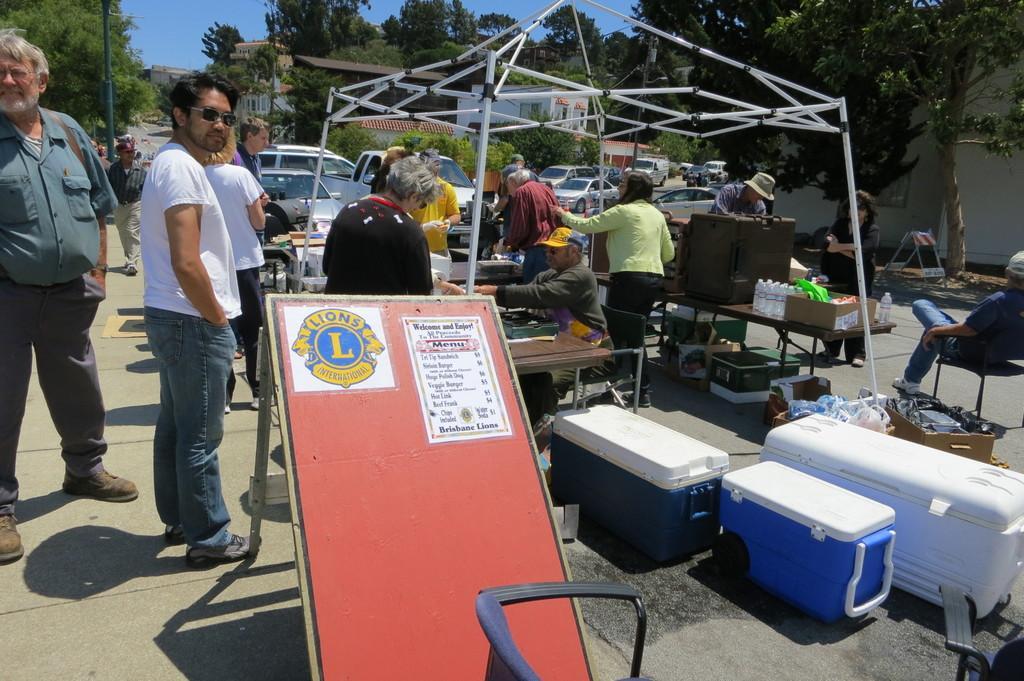How would you summarize this image in a sentence or two? In this image we can see few people standing on the road and few people sitting on the chairs, there are few boxes and few objects in some boxes and there are few bottles, boxes and few objects on the tables and there is a structure with iron rods, there is a board with logo and text, and in the background there are few cars on the road and few buildings, trees. 